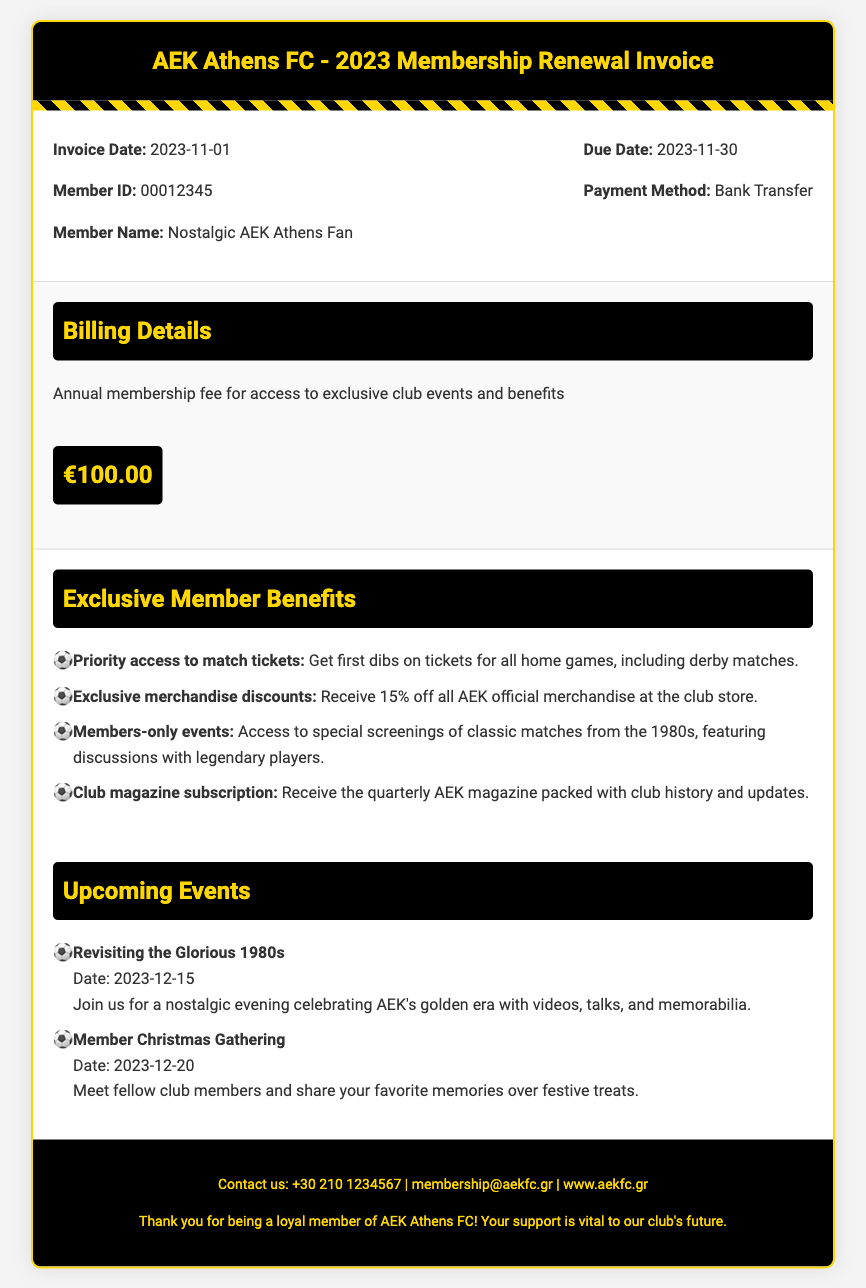What is the invoice date? The invoice date is mentioned at the top of the invoice details section.
Answer: 2023-11-01 What is the member ID? The member ID is specified in the invoice details, which is unique for each member.
Answer: 00012345 What is the total annual membership fee? The total annual membership fee is indicated in the billing details section.
Answer: €100.00 What percentage discount do members receive on merchandise? The discount percentage for members on official merchandise is stated in the exclusive member benefits section.
Answer: 15% What is the date of the event "Revisiting the Glorious 1980s"? The date for this event is listed under the upcoming events section.
Answer: 2023-12-15 How many upcoming events are listed in the document? The number of upcoming events can be counted in the upcoming events section.
Answer: 2 What kind of benefits do members have regarding match tickets? The specific benefit related to match tickets is detailed in the exclusive member benefits section.
Answer: Priority access When is the member Christmas gathering scheduled? The date for the gathering is provided in the upcoming events section.
Answer: 2023-12-20 